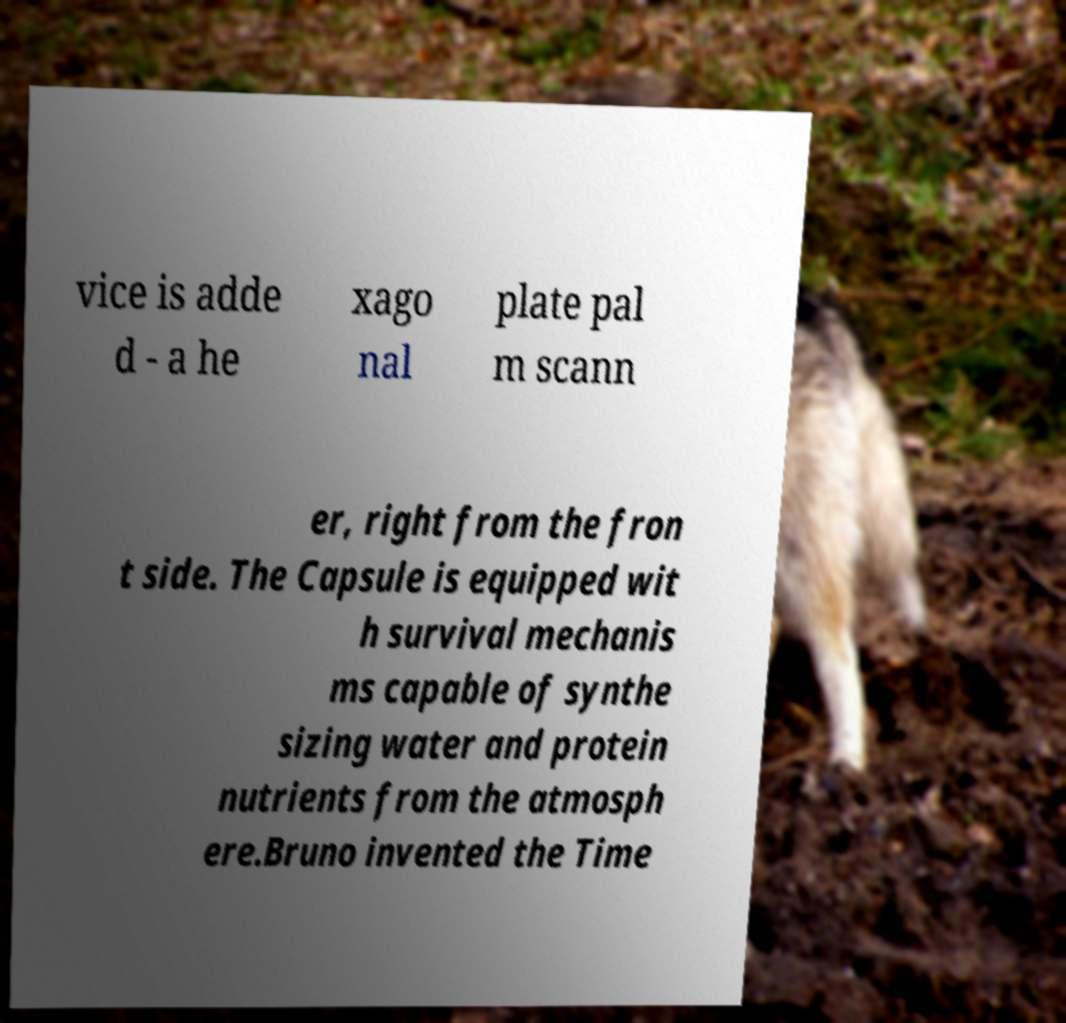Could you assist in decoding the text presented in this image and type it out clearly? vice is adde d - a he xago nal plate pal m scann er, right from the fron t side. The Capsule is equipped wit h survival mechanis ms capable of synthe sizing water and protein nutrients from the atmosph ere.Bruno invented the Time 